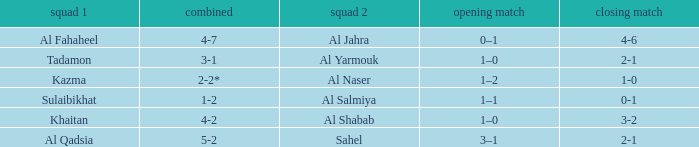Help me parse the entirety of this table. {'header': ['squad 1', 'combined', 'squad 2', 'opening match', 'closing match'], 'rows': [['Al Fahaheel', '4-7', 'Al Jahra', '0–1', '4-6'], ['Tadamon', '3-1', 'Al Yarmouk', '1–0', '2-1'], ['Kazma', '2-2*', 'Al Naser', '1–2', '1-0'], ['Sulaibikhat', '1-2', 'Al Salmiya', '1–1', '0-1'], ['Khaitan', '4-2', 'Al Shabab', '1–0', '3-2'], ['Al Qadsia', '5-2', 'Sahel', '3–1', '2-1']]} What is the 1st leg of the match with a 2nd leg of 3-2? 1–0. 